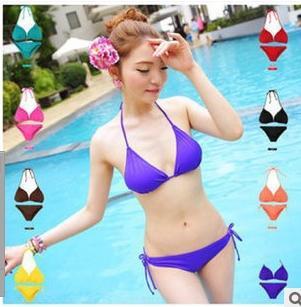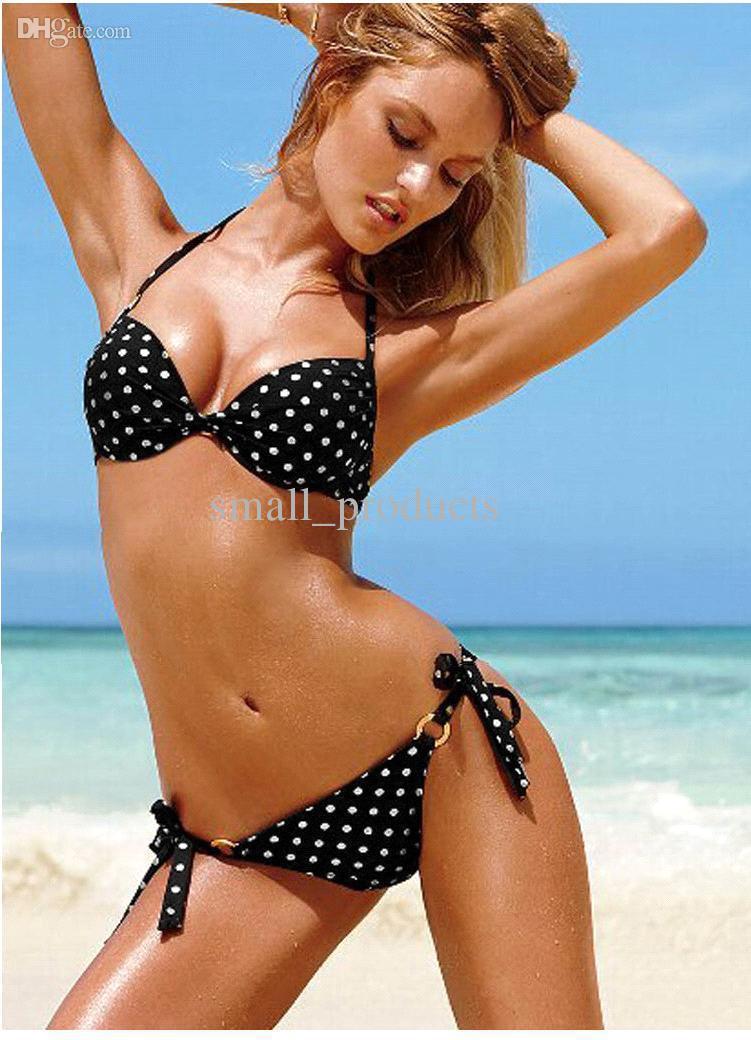The first image is the image on the left, the second image is the image on the right. Evaluate the accuracy of this statement regarding the images: "Thr right image shows a blonde bikini model with at least one arm raised to her hair and her hip jutted to the right.". Is it true? Answer yes or no. Yes. 